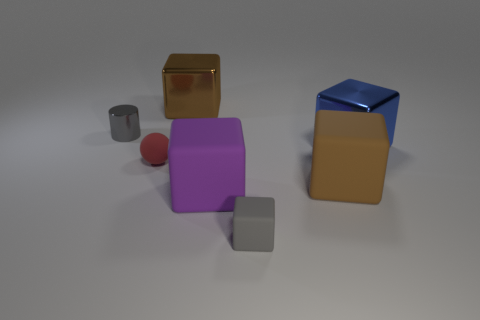Subtract all gray blocks. How many blocks are left? 4 Subtract all brown metal cubes. How many cubes are left? 4 Subtract all yellow blocks. Subtract all yellow spheres. How many blocks are left? 5 Add 2 large brown shiny objects. How many objects exist? 9 Subtract all spheres. How many objects are left? 6 Subtract 0 red blocks. How many objects are left? 7 Subtract all gray rubber cubes. Subtract all big brown cubes. How many objects are left? 4 Add 1 big blue blocks. How many big blue blocks are left? 2 Add 3 cylinders. How many cylinders exist? 4 